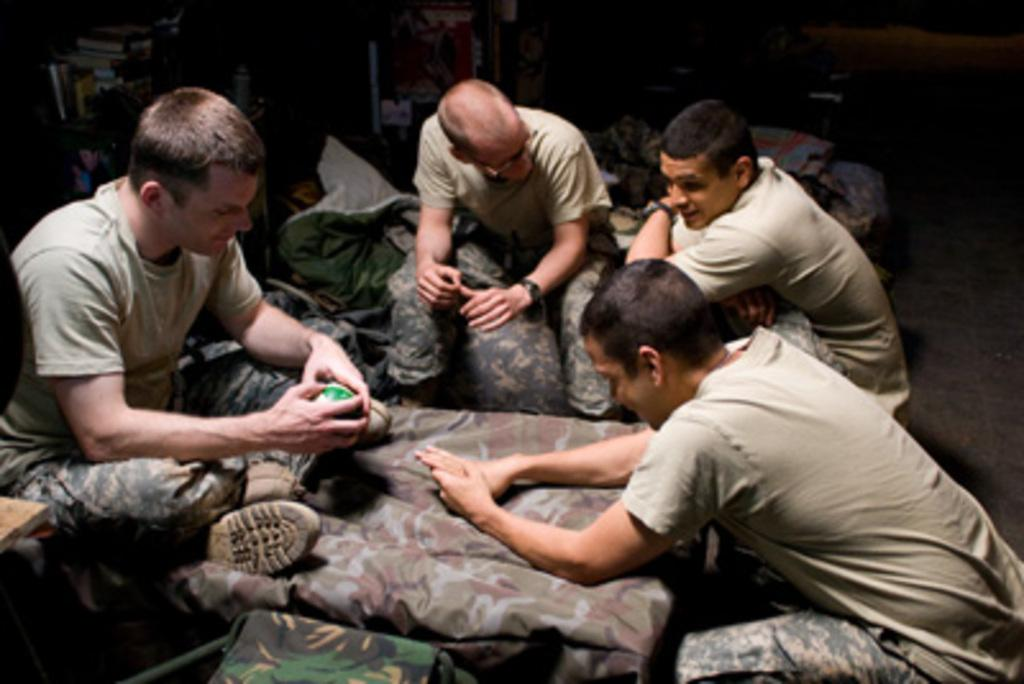What type of people can be seen in the image? There are soldiers in the image. What type of furniture is present in the image? There are beds in the image. Can you describe any other objects in the image? There are other objects in the image, but their specific details are not mentioned in the provided facts. What can be seen in the background of the image? There are shelves in the background of the image. What is on the shelves in the background? There are books on the shelves in the background. Reasoning: Let'g: Let's think step by step in order to produce the conversation. We start by identifying the main subjects in the image, which are the soldiers. Then, we describe the furniture present in the image, which are the beds. Next, we acknowledge the presence of other objects in the image, but since their specific details are not mentioned, we leave it open-ended. Finally, we describe the background of the image, which includes shelves with books. Absurd Question/Answer: Can you tell me how many beetles are crawling on the books in the image? There are no beetles present in the image; only soldiers, beds, and books are visible. What type of jar is used to store the soldier's belongings in the image? There is no jar mentioned or visible in the image. 